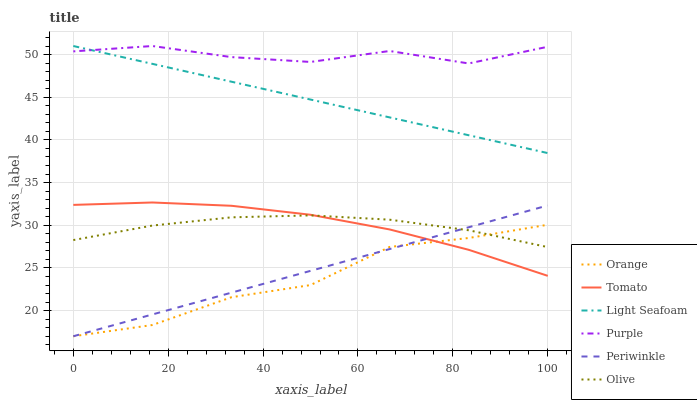Does Orange have the minimum area under the curve?
Answer yes or no. Yes. Does Purple have the maximum area under the curve?
Answer yes or no. Yes. Does Olive have the minimum area under the curve?
Answer yes or no. No. Does Olive have the maximum area under the curve?
Answer yes or no. No. Is Periwinkle the smoothest?
Answer yes or no. Yes. Is Orange the roughest?
Answer yes or no. Yes. Is Purple the smoothest?
Answer yes or no. No. Is Purple the roughest?
Answer yes or no. No. Does Periwinkle have the lowest value?
Answer yes or no. Yes. Does Olive have the lowest value?
Answer yes or no. No. Does Light Seafoam have the highest value?
Answer yes or no. Yes. Does Olive have the highest value?
Answer yes or no. No. Is Orange less than Purple?
Answer yes or no. Yes. Is Light Seafoam greater than Periwinkle?
Answer yes or no. Yes. Does Olive intersect Orange?
Answer yes or no. Yes. Is Olive less than Orange?
Answer yes or no. No. Is Olive greater than Orange?
Answer yes or no. No. Does Orange intersect Purple?
Answer yes or no. No. 